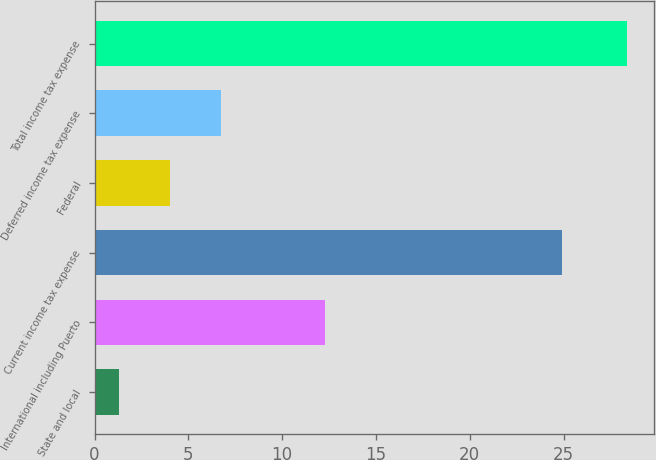Convert chart to OTSL. <chart><loc_0><loc_0><loc_500><loc_500><bar_chart><fcel>State and local<fcel>International including Puerto<fcel>Current income tax expense<fcel>Federal<fcel>Deferred income tax expense<fcel>Total income tax expense<nl><fcel>1.3<fcel>12.3<fcel>24.9<fcel>4.01<fcel>6.72<fcel>28.4<nl></chart> 